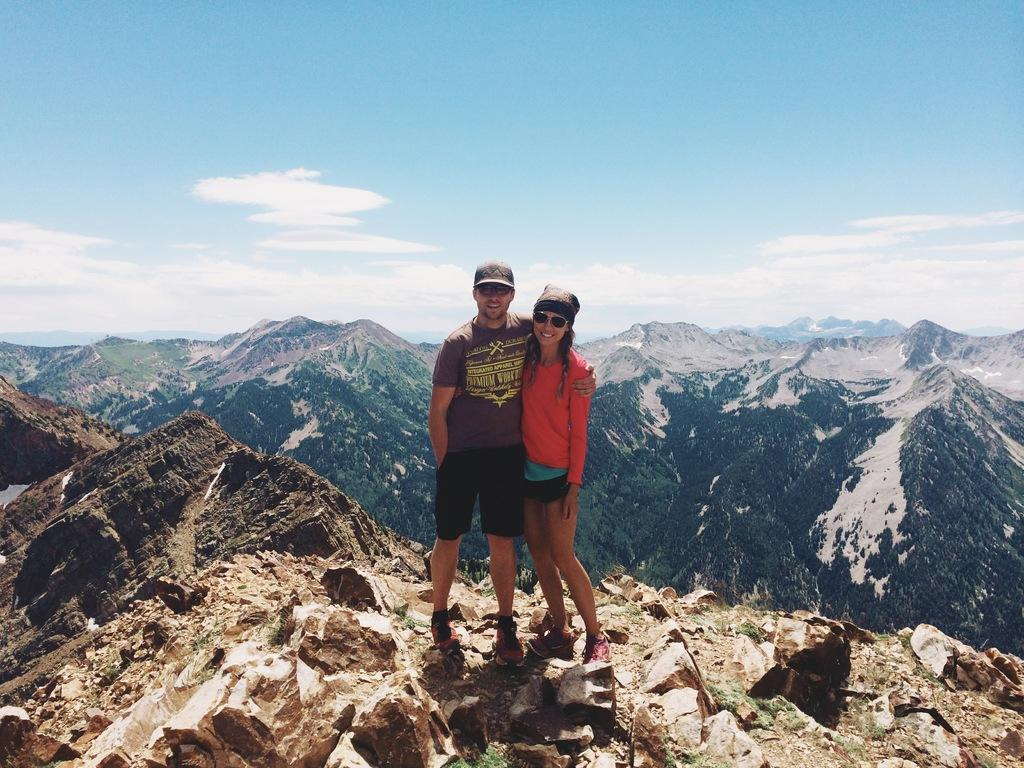How many people are in the image? There are two persons in the image. What are the persons wearing on their heads? The persons are wearing caps. What type of footwear are the persons wearing? The persons are wearing shoes. Where are the persons standing in the image? The persons are standing on a hill. What type of natural features can be seen in the image? There are rocks visible in the image, and mountains can be seen in the background. What is visible in the sky in the image? The sky is visible in the background of the image, and clouds are present. What is the cause of the legs in the image? There are no legs mentioned in the image; the persons are wearing shoes, but their legs are not the focus of the image. 